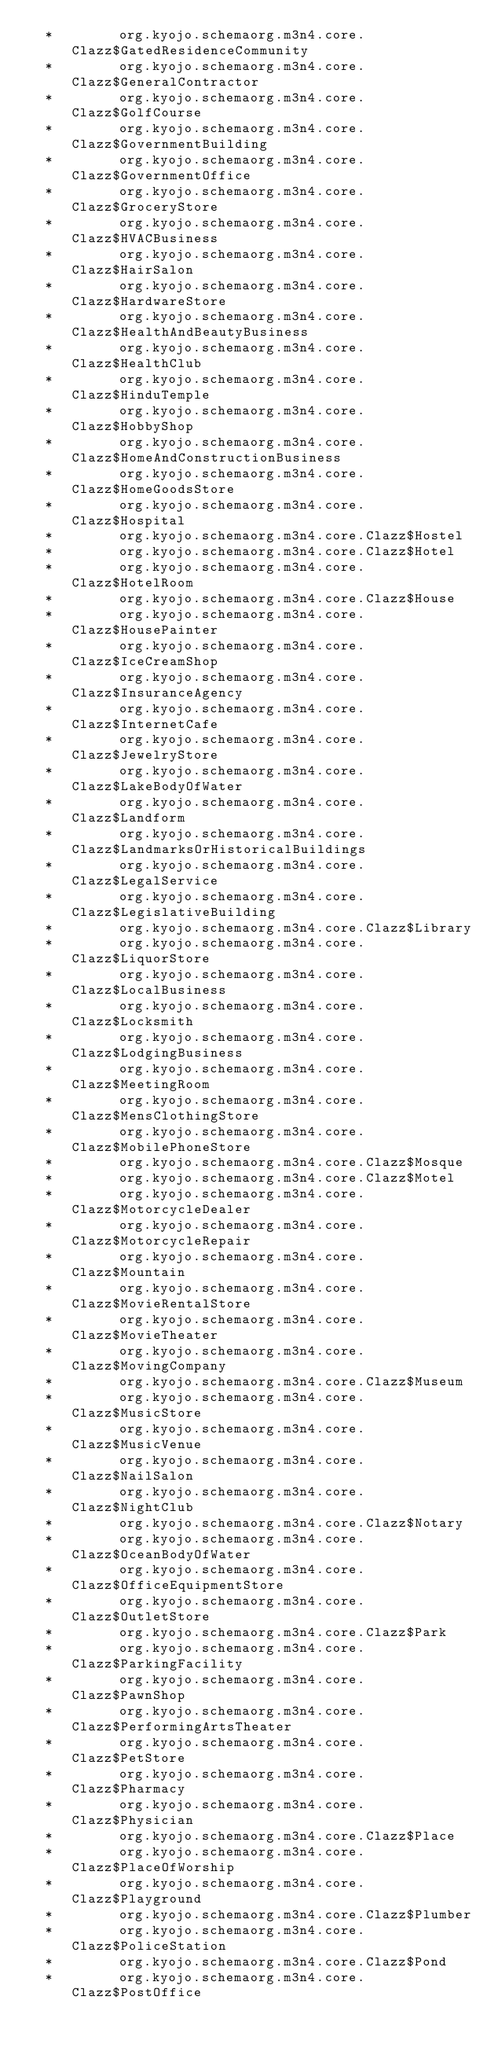Convert code to text. <code><loc_0><loc_0><loc_500><loc_500><_SQL_>  *        org.kyojo.schemaorg.m3n4.core.Clazz$GatedResidenceCommunity
  *        org.kyojo.schemaorg.m3n4.core.Clazz$GeneralContractor
  *        org.kyojo.schemaorg.m3n4.core.Clazz$GolfCourse
  *        org.kyojo.schemaorg.m3n4.core.Clazz$GovernmentBuilding
  *        org.kyojo.schemaorg.m3n4.core.Clazz$GovernmentOffice
  *        org.kyojo.schemaorg.m3n4.core.Clazz$GroceryStore
  *        org.kyojo.schemaorg.m3n4.core.Clazz$HVACBusiness
  *        org.kyojo.schemaorg.m3n4.core.Clazz$HairSalon
  *        org.kyojo.schemaorg.m3n4.core.Clazz$HardwareStore
  *        org.kyojo.schemaorg.m3n4.core.Clazz$HealthAndBeautyBusiness
  *        org.kyojo.schemaorg.m3n4.core.Clazz$HealthClub
  *        org.kyojo.schemaorg.m3n4.core.Clazz$HinduTemple
  *        org.kyojo.schemaorg.m3n4.core.Clazz$HobbyShop
  *        org.kyojo.schemaorg.m3n4.core.Clazz$HomeAndConstructionBusiness
  *        org.kyojo.schemaorg.m3n4.core.Clazz$HomeGoodsStore
  *        org.kyojo.schemaorg.m3n4.core.Clazz$Hospital
  *        org.kyojo.schemaorg.m3n4.core.Clazz$Hostel
  *        org.kyojo.schemaorg.m3n4.core.Clazz$Hotel
  *        org.kyojo.schemaorg.m3n4.core.Clazz$HotelRoom
  *        org.kyojo.schemaorg.m3n4.core.Clazz$House
  *        org.kyojo.schemaorg.m3n4.core.Clazz$HousePainter
  *        org.kyojo.schemaorg.m3n4.core.Clazz$IceCreamShop
  *        org.kyojo.schemaorg.m3n4.core.Clazz$InsuranceAgency
  *        org.kyojo.schemaorg.m3n4.core.Clazz$InternetCafe
  *        org.kyojo.schemaorg.m3n4.core.Clazz$JewelryStore
  *        org.kyojo.schemaorg.m3n4.core.Clazz$LakeBodyOfWater
  *        org.kyojo.schemaorg.m3n4.core.Clazz$Landform
  *        org.kyojo.schemaorg.m3n4.core.Clazz$LandmarksOrHistoricalBuildings
  *        org.kyojo.schemaorg.m3n4.core.Clazz$LegalService
  *        org.kyojo.schemaorg.m3n4.core.Clazz$LegislativeBuilding
  *        org.kyojo.schemaorg.m3n4.core.Clazz$Library
  *        org.kyojo.schemaorg.m3n4.core.Clazz$LiquorStore
  *        org.kyojo.schemaorg.m3n4.core.Clazz$LocalBusiness
  *        org.kyojo.schemaorg.m3n4.core.Clazz$Locksmith
  *        org.kyojo.schemaorg.m3n4.core.Clazz$LodgingBusiness
  *        org.kyojo.schemaorg.m3n4.core.Clazz$MeetingRoom
  *        org.kyojo.schemaorg.m3n4.core.Clazz$MensClothingStore
  *        org.kyojo.schemaorg.m3n4.core.Clazz$MobilePhoneStore
  *        org.kyojo.schemaorg.m3n4.core.Clazz$Mosque
  *        org.kyojo.schemaorg.m3n4.core.Clazz$Motel
  *        org.kyojo.schemaorg.m3n4.core.Clazz$MotorcycleDealer
  *        org.kyojo.schemaorg.m3n4.core.Clazz$MotorcycleRepair
  *        org.kyojo.schemaorg.m3n4.core.Clazz$Mountain
  *        org.kyojo.schemaorg.m3n4.core.Clazz$MovieRentalStore
  *        org.kyojo.schemaorg.m3n4.core.Clazz$MovieTheater
  *        org.kyojo.schemaorg.m3n4.core.Clazz$MovingCompany
  *        org.kyojo.schemaorg.m3n4.core.Clazz$Museum
  *        org.kyojo.schemaorg.m3n4.core.Clazz$MusicStore
  *        org.kyojo.schemaorg.m3n4.core.Clazz$MusicVenue
  *        org.kyojo.schemaorg.m3n4.core.Clazz$NailSalon
  *        org.kyojo.schemaorg.m3n4.core.Clazz$NightClub
  *        org.kyojo.schemaorg.m3n4.core.Clazz$Notary
  *        org.kyojo.schemaorg.m3n4.core.Clazz$OceanBodyOfWater
  *        org.kyojo.schemaorg.m3n4.core.Clazz$OfficeEquipmentStore
  *        org.kyojo.schemaorg.m3n4.core.Clazz$OutletStore
  *        org.kyojo.schemaorg.m3n4.core.Clazz$Park
  *        org.kyojo.schemaorg.m3n4.core.Clazz$ParkingFacility
  *        org.kyojo.schemaorg.m3n4.core.Clazz$PawnShop
  *        org.kyojo.schemaorg.m3n4.core.Clazz$PerformingArtsTheater
  *        org.kyojo.schemaorg.m3n4.core.Clazz$PetStore
  *        org.kyojo.schemaorg.m3n4.core.Clazz$Pharmacy
  *        org.kyojo.schemaorg.m3n4.core.Clazz$Physician
  *        org.kyojo.schemaorg.m3n4.core.Clazz$Place
  *        org.kyojo.schemaorg.m3n4.core.Clazz$PlaceOfWorship
  *        org.kyojo.schemaorg.m3n4.core.Clazz$Playground
  *        org.kyojo.schemaorg.m3n4.core.Clazz$Plumber
  *        org.kyojo.schemaorg.m3n4.core.Clazz$PoliceStation
  *        org.kyojo.schemaorg.m3n4.core.Clazz$Pond
  *        org.kyojo.schemaorg.m3n4.core.Clazz$PostOffice</code> 